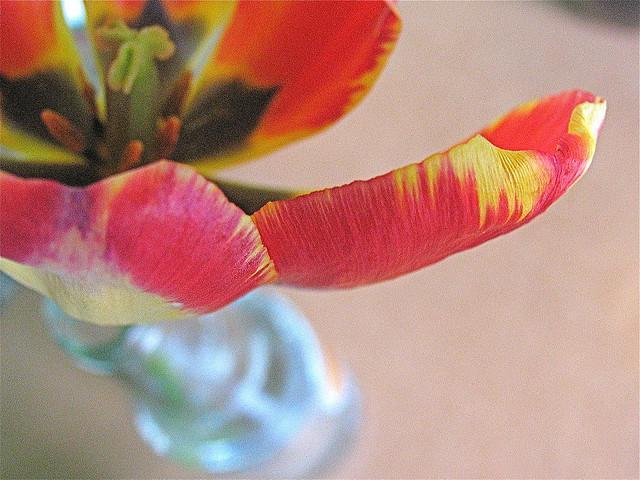How many potted plants are in the photo?
Give a very brief answer. 1. 